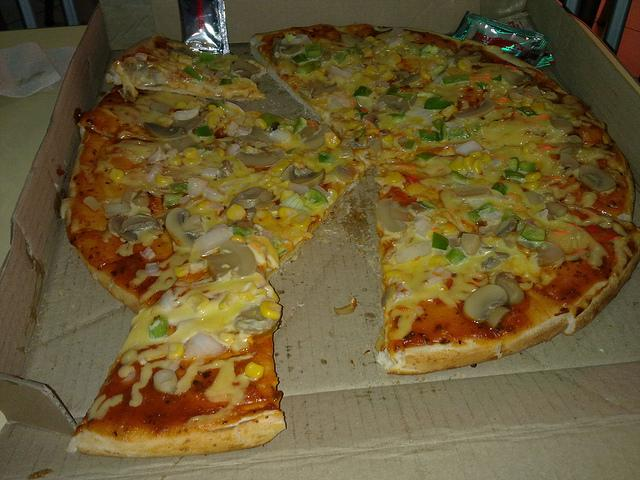What vegetable is the unusual one on the pizza? Please explain your reasoning. corn. Normally corn is not on pizza. 